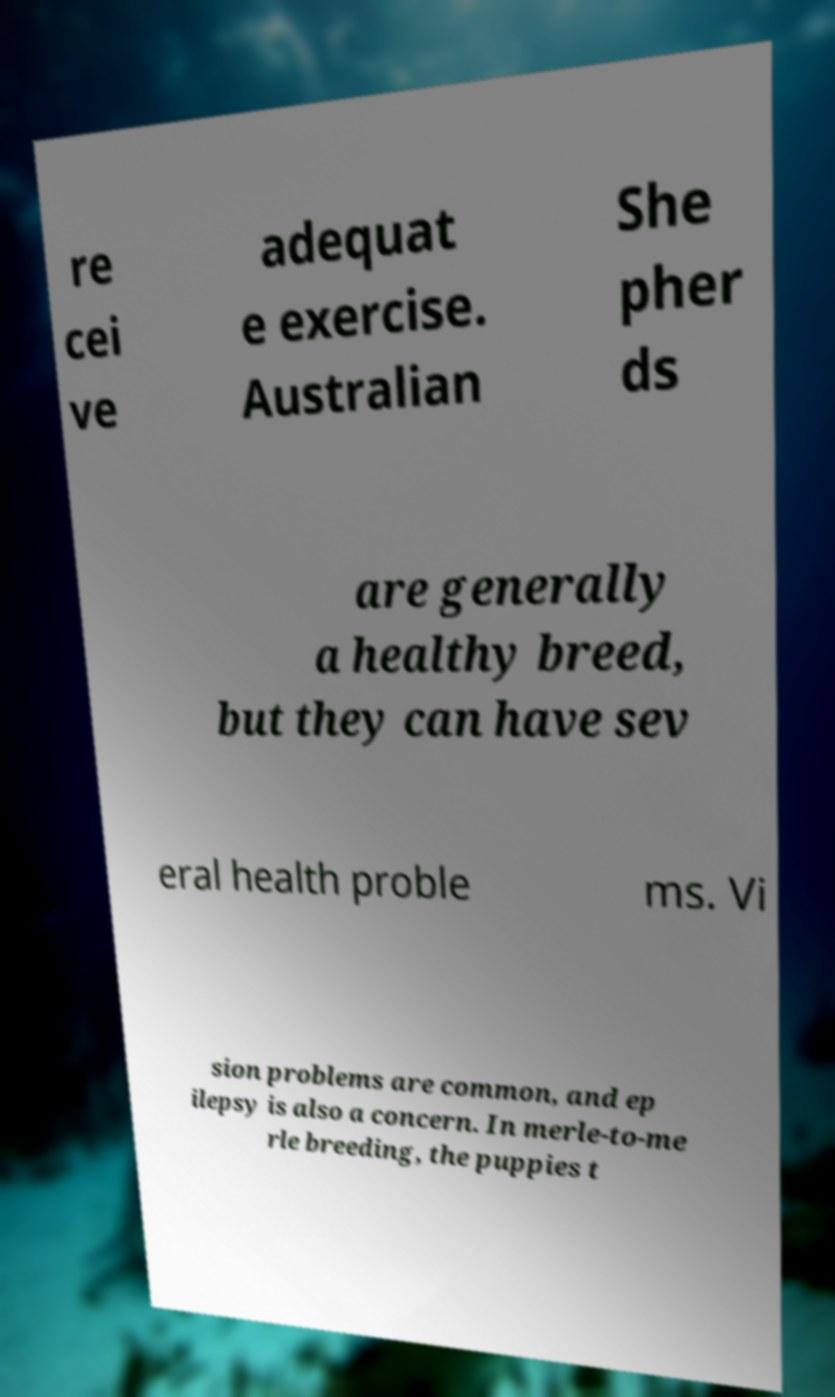Can you read and provide the text displayed in the image?This photo seems to have some interesting text. Can you extract and type it out for me? re cei ve adequat e exercise. Australian She pher ds are generally a healthy breed, but they can have sev eral health proble ms. Vi sion problems are common, and ep ilepsy is also a concern. In merle-to-me rle breeding, the puppies t 